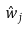Convert formula to latex. <formula><loc_0><loc_0><loc_500><loc_500>\hat { w } _ { j }</formula> 